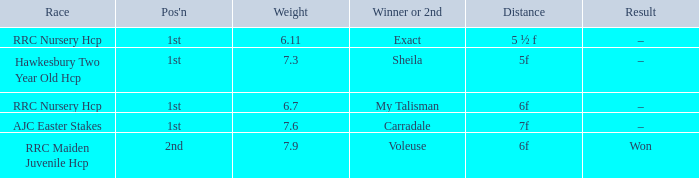What was the distance when the weight was 6.11? 5 ½ f. 